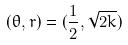<formula> <loc_0><loc_0><loc_500><loc_500>( \theta , r ) = ( \frac { 1 } { 2 } , \sqrt { 2 k } )</formula> 